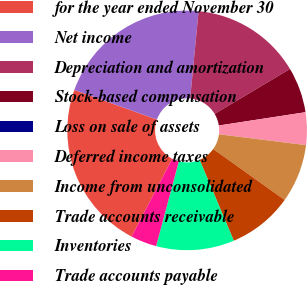<chart> <loc_0><loc_0><loc_500><loc_500><pie_chart><fcel>for the year ended November 30<fcel>Net income<fcel>Depreciation and amortization<fcel>Stock-based compensation<fcel>Loss on sale of assets<fcel>Deferred income taxes<fcel>Income from unconsolidated<fcel>Trade accounts receivable<fcel>Inventories<fcel>Trade accounts payable<nl><fcel>22.81%<fcel>21.05%<fcel>14.91%<fcel>6.14%<fcel>0.0%<fcel>4.39%<fcel>7.9%<fcel>8.77%<fcel>10.53%<fcel>3.51%<nl></chart> 